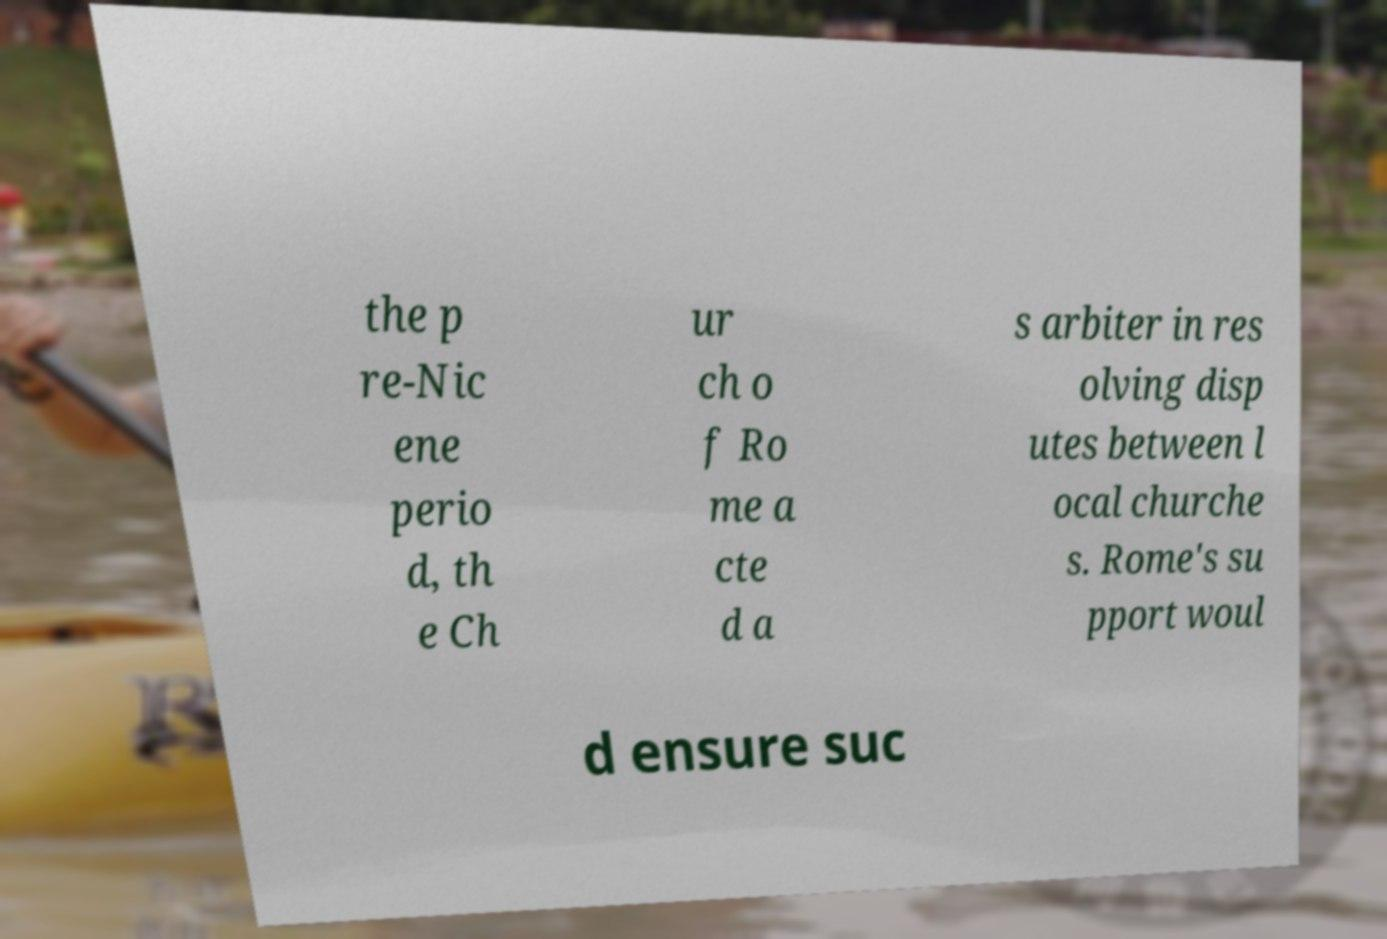Can you accurately transcribe the text from the provided image for me? the p re-Nic ene perio d, th e Ch ur ch o f Ro me a cte d a s arbiter in res olving disp utes between l ocal churche s. Rome's su pport woul d ensure suc 